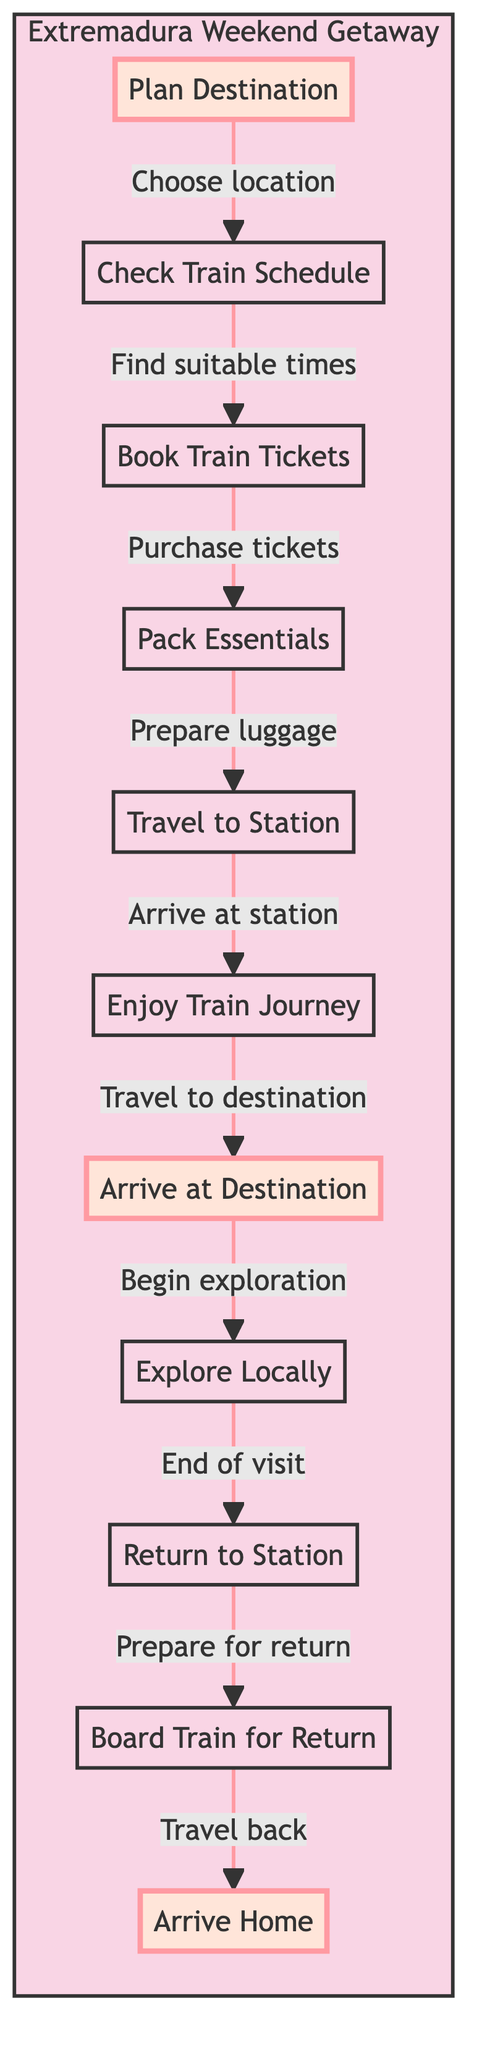What is the first step in the flow? The first step in the flow chart is labeled "Plan Destination." This indicates that choosing a destination is the starting point for planning the weekend getaway.
Answer: Plan Destination How many nodes are in the chart? By counting each of the activities listed from "Plan Destination" to "Arrive Home," we see there are 11 distinct nodes in the chart, representing different steps in the process.
Answer: 11 What is the last activity before returning home? The last activity before arriving home is "Board Train for Return." It signifies that after exploring the destination, the traveler boards the train to go back to their original station.
Answer: Board Train for Return Which node signifies beginning exploration? The node that signifies the beginning of exploration is "Arrive at Destination." This step highlights the transition from travel to starting the local exploration activities during the getaway.
Answer: Arrive at Destination What are the two activities that follow "Check Train Schedule"? After "Check Train Schedule," the next two activities are "Book Train Tickets" and then "Pack Essentials." This indicates a progression from planning to the preparation stage for the trip.
Answer: Book Train Tickets, Pack Essentials What is the relationship between "Enjoy Train Journey" and "Arrive at Destination"? The relationship is sequential; after completing the "Enjoy Train Journey," you then "Arrive at Destination." This shows a clear flow from enjoying the train ride to reaching the chosen location.
Answer: Enjoy Train Journey → Arrive at Destination What signifies the end of the local exploration? The node that signifies the end of local exploration is "Return to Station," indicating the traveler has completed their visits and is preparing to go back.
Answer: Return to Station What activity comes directly after "Pack Essentials"? The activity that comes directly after "Pack Essentials" is "Travel to Station." This shows that packing is immediately followed by making the journey to the train station for departure.
Answer: Travel to Station What is the primary focus of the flow chart? The primary focus of the flow chart is to outline the sequential activities involved in planning and executing a weekend getaway in Extremadura, from departure to returning home.
Answer: Weekend Getaway in Extremadura 